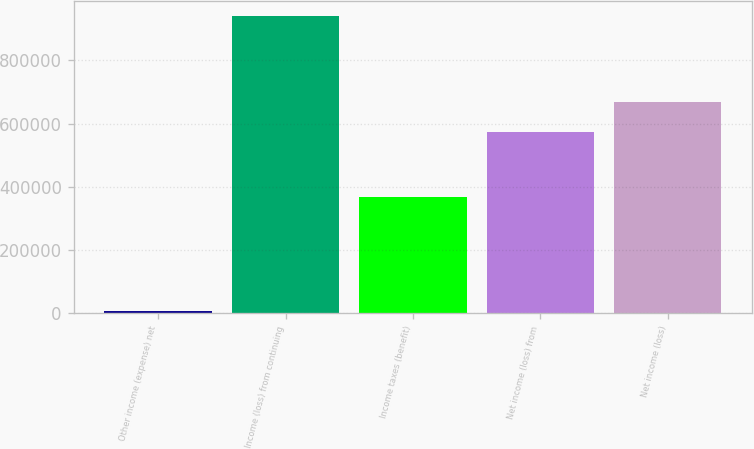Convert chart to OTSL. <chart><loc_0><loc_0><loc_500><loc_500><bar_chart><fcel>Other income (expense) net<fcel>Income (loss) from continuing<fcel>Income taxes (benefit)<fcel>Net income (loss) from<fcel>Net income (loss)<nl><fcel>6461<fcel>941090<fcel>367660<fcel>573430<fcel>666893<nl></chart> 